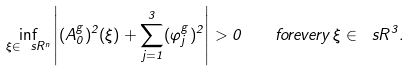Convert formula to latex. <formula><loc_0><loc_0><loc_500><loc_500>\inf _ { \xi \in \ s R ^ { n } } \left | ( A _ { 0 } ^ { g } ) ^ { 2 } ( \xi ) + \sum _ { j = 1 } ^ { 3 } ( \varphi _ { j } ^ { g } ) ^ { 2 } \right | > 0 \quad f o r e v e r y \, \xi \in \ s R ^ { 3 } .</formula> 